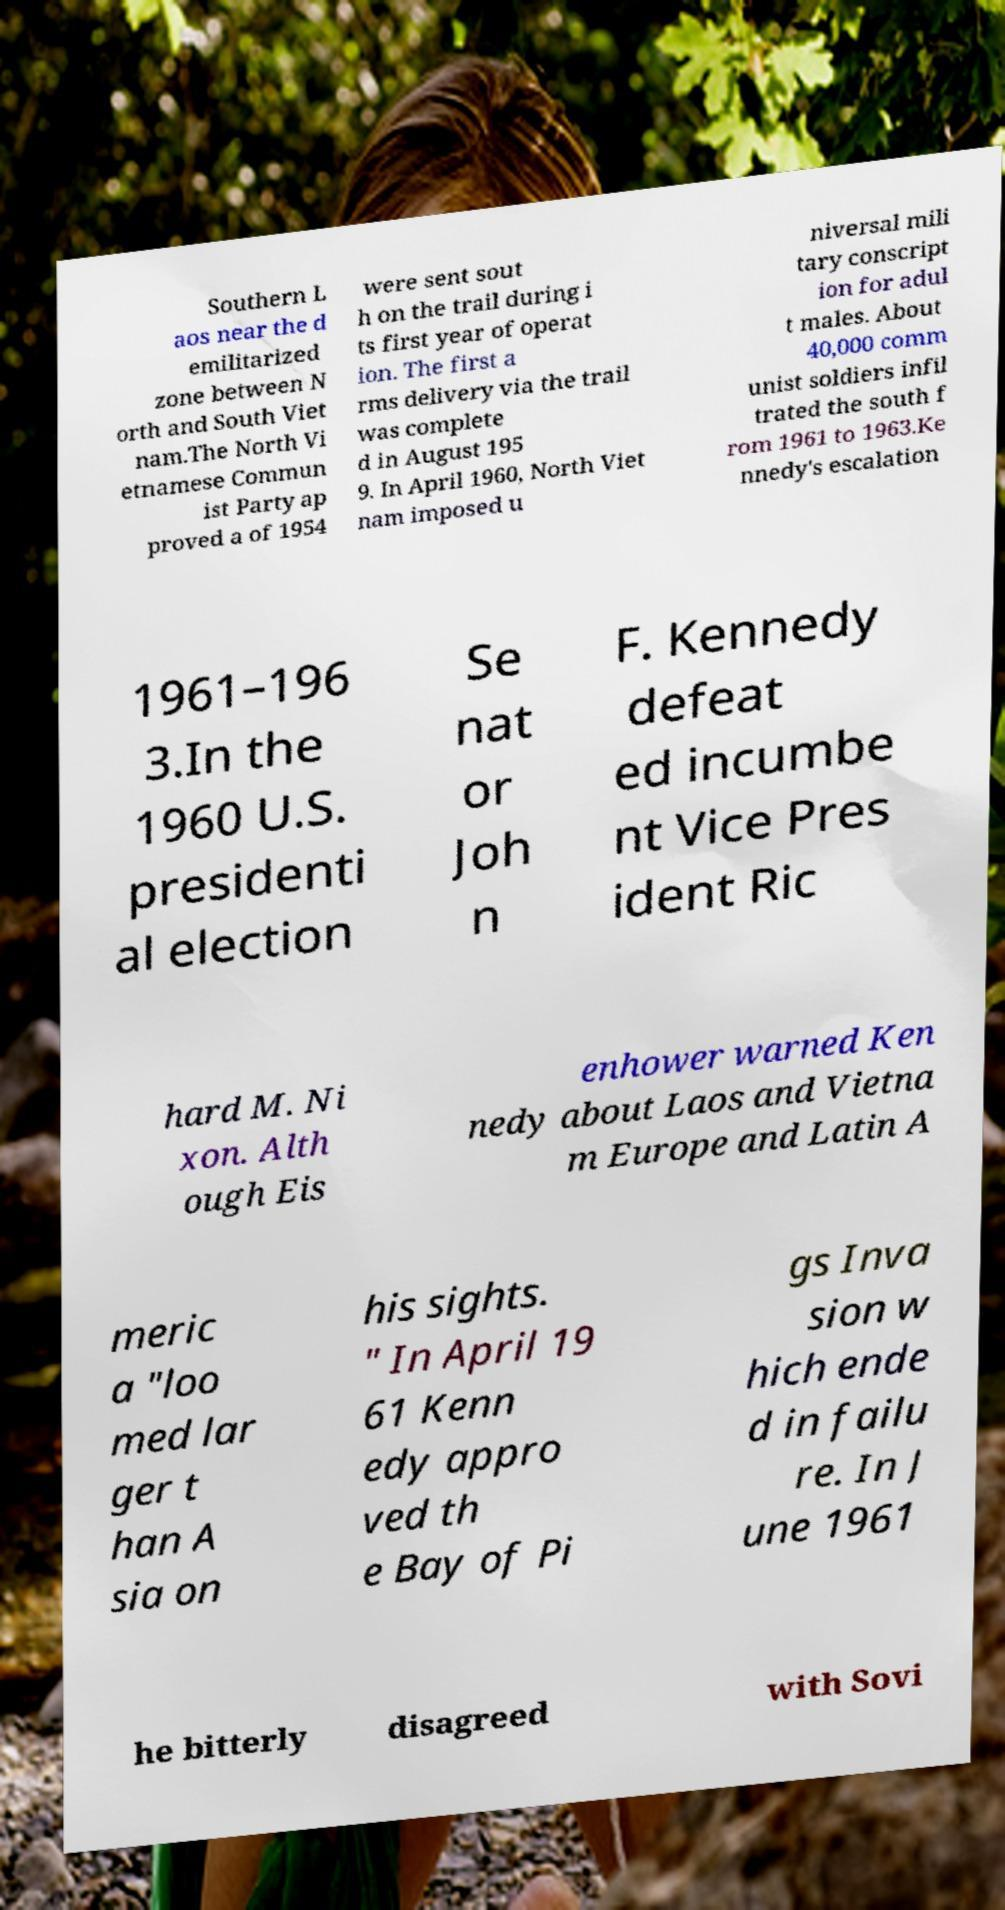Can you accurately transcribe the text from the provided image for me? Southern L aos near the d emilitarized zone between N orth and South Viet nam.The North Vi etnamese Commun ist Party ap proved a of 1954 were sent sout h on the trail during i ts first year of operat ion. The first a rms delivery via the trail was complete d in August 195 9. In April 1960, North Viet nam imposed u niversal mili tary conscript ion for adul t males. About 40,000 comm unist soldiers infil trated the south f rom 1961 to 1963.Ke nnedy's escalation 1961–196 3.In the 1960 U.S. presidenti al election Se nat or Joh n F. Kennedy defeat ed incumbe nt Vice Pres ident Ric hard M. Ni xon. Alth ough Eis enhower warned Ken nedy about Laos and Vietna m Europe and Latin A meric a "loo med lar ger t han A sia on his sights. " In April 19 61 Kenn edy appro ved th e Bay of Pi gs Inva sion w hich ende d in failu re. In J une 1961 he bitterly disagreed with Sovi 